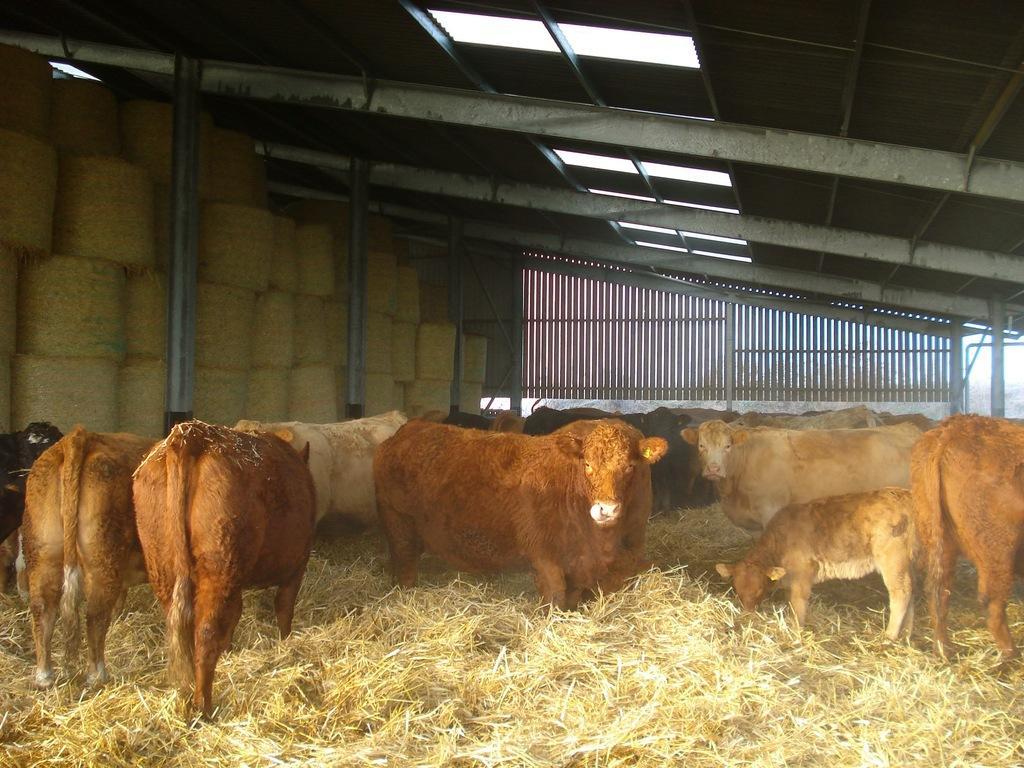Please provide a concise description of this image. In this picture there are animals under the shed. At the back there is a railing. At the top there are lights. At the bottom there is grass. 